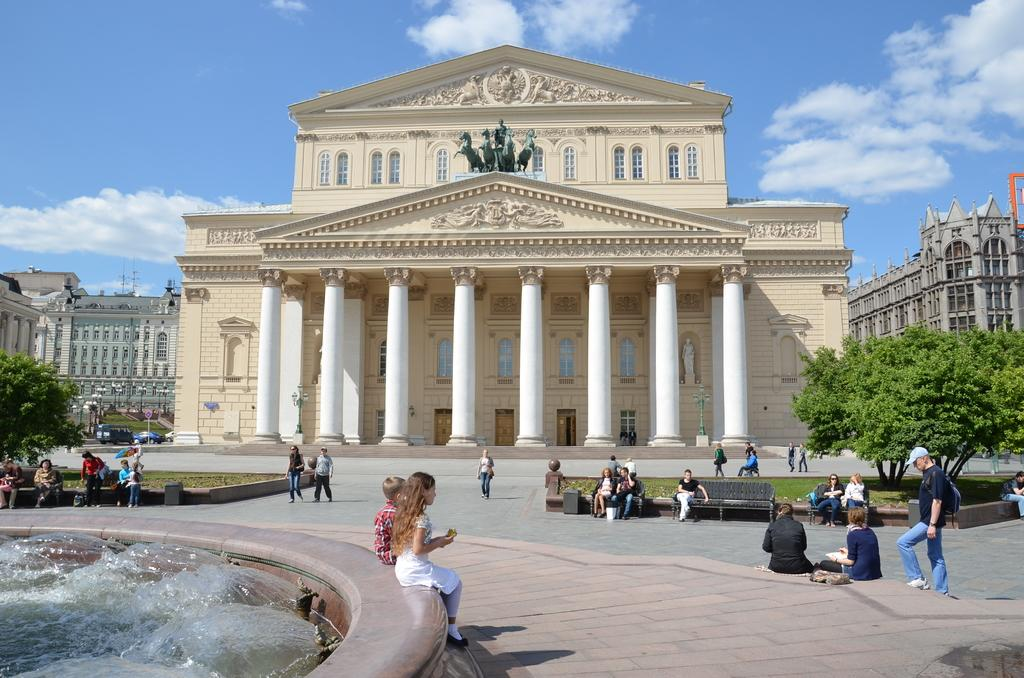How many people can be seen in the image? There are persons in the image, but the exact number cannot be determined from the provided facts. What architectural features are present in the image? There are present in the image. A: There are pillars and buildings in the image. What type of artwork is visible in the image? There are sculptures in the image. What type of seating is available in the image? There are benches in the image. What mode of transportation is visible in the image? There are vehicles in the image. What natural elements can be seen in the image? There are trees and water visible in the image. What is visible in the background of the image? The sky is visible in the background of the image, with clouds present. What type of brick is used to build the wall surrounding the dog in the image? There is no wall or dog present in the image; the facts mention pillars, buildings, and sculptures, but not a wall or dog. 